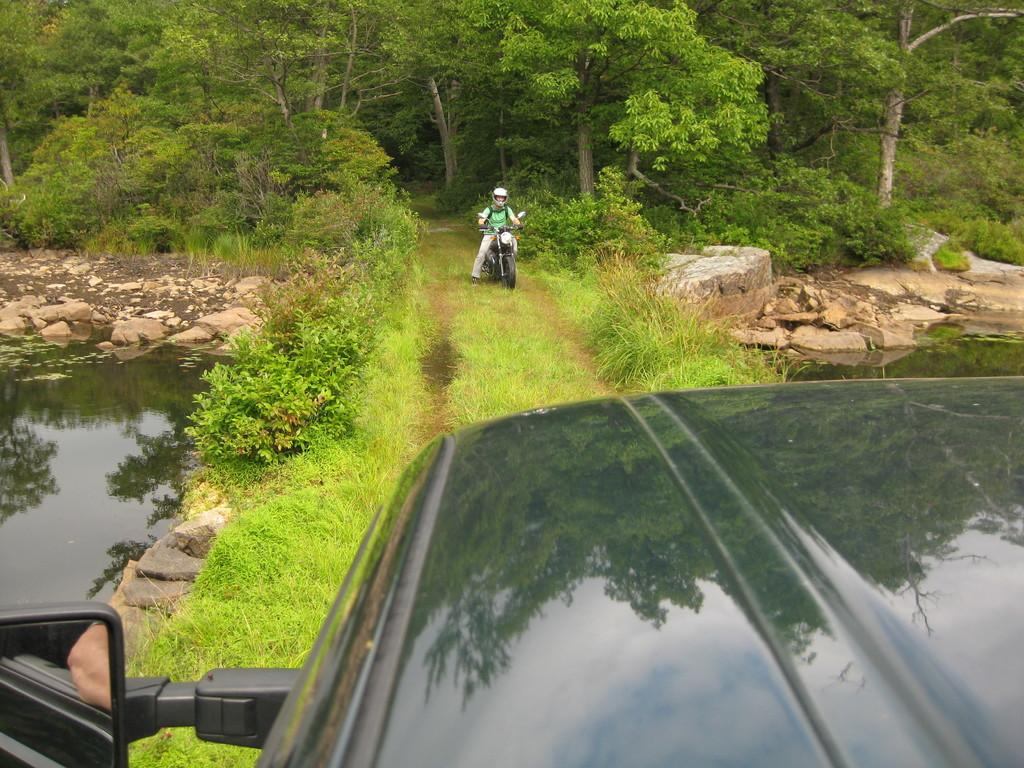What is the main subject of the image? There is a person riding a motorbike in the image. What else can be seen in the foreground of the image? There is a car in the foreground of the image. What type of natural environment is visible in the background of the image? There are trees and plants in the background of the image. What type of terrain is visible at the bottom of the image? There are stones at the bottom of the image. What time of day is the discussion taking place in the image? There is no discussion taking place in the image, as it features a person riding a motorbike and a car in the foreground. Is there a volcano visible in the image? No, there is no volcano present in the image. 